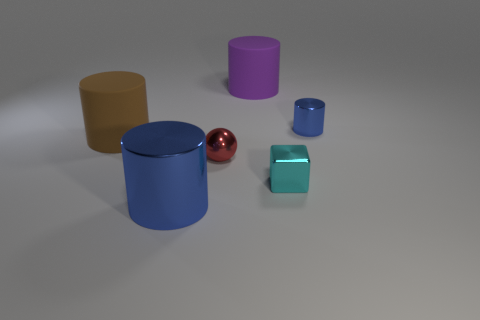Subtract all big blue cylinders. How many cylinders are left? 3 Subtract all blue spheres. How many blue cylinders are left? 2 Add 3 large purple rubber cylinders. How many objects exist? 9 Subtract all brown cylinders. How many cylinders are left? 3 Subtract 1 cylinders. How many cylinders are left? 3 Subtract all blocks. How many objects are left? 5 Add 3 blocks. How many blocks are left? 4 Add 1 small green things. How many small green things exist? 1 Subtract 0 yellow cylinders. How many objects are left? 6 Subtract all green cylinders. Subtract all red spheres. How many cylinders are left? 4 